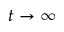<formula> <loc_0><loc_0><loc_500><loc_500>t \rightarrow \infty</formula> 